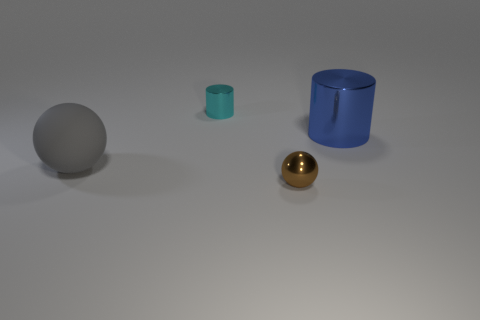Add 3 rubber spheres. How many objects exist? 7 Subtract all red shiny cylinders. Subtract all small spheres. How many objects are left? 3 Add 4 metallic things. How many metallic things are left? 7 Add 4 red metal cylinders. How many red metal cylinders exist? 4 Subtract 1 brown spheres. How many objects are left? 3 